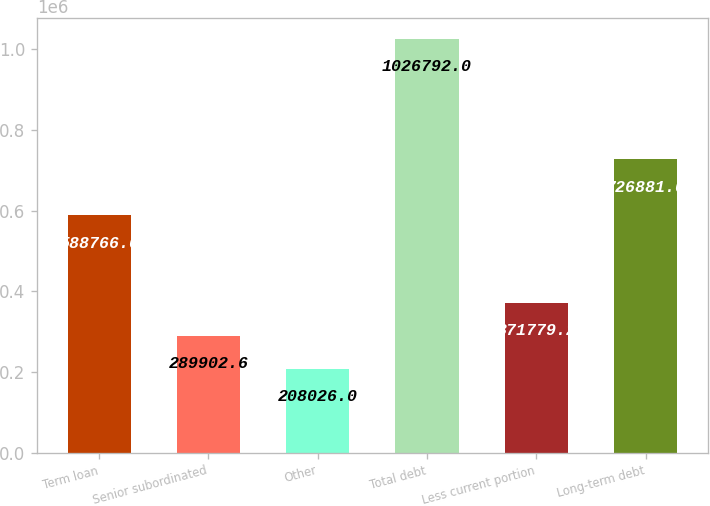Convert chart to OTSL. <chart><loc_0><loc_0><loc_500><loc_500><bar_chart><fcel>Term loan<fcel>Senior subordinated<fcel>Other<fcel>Total debt<fcel>Less current portion<fcel>Long-term debt<nl><fcel>588766<fcel>289903<fcel>208026<fcel>1.02679e+06<fcel>371779<fcel>726881<nl></chart> 